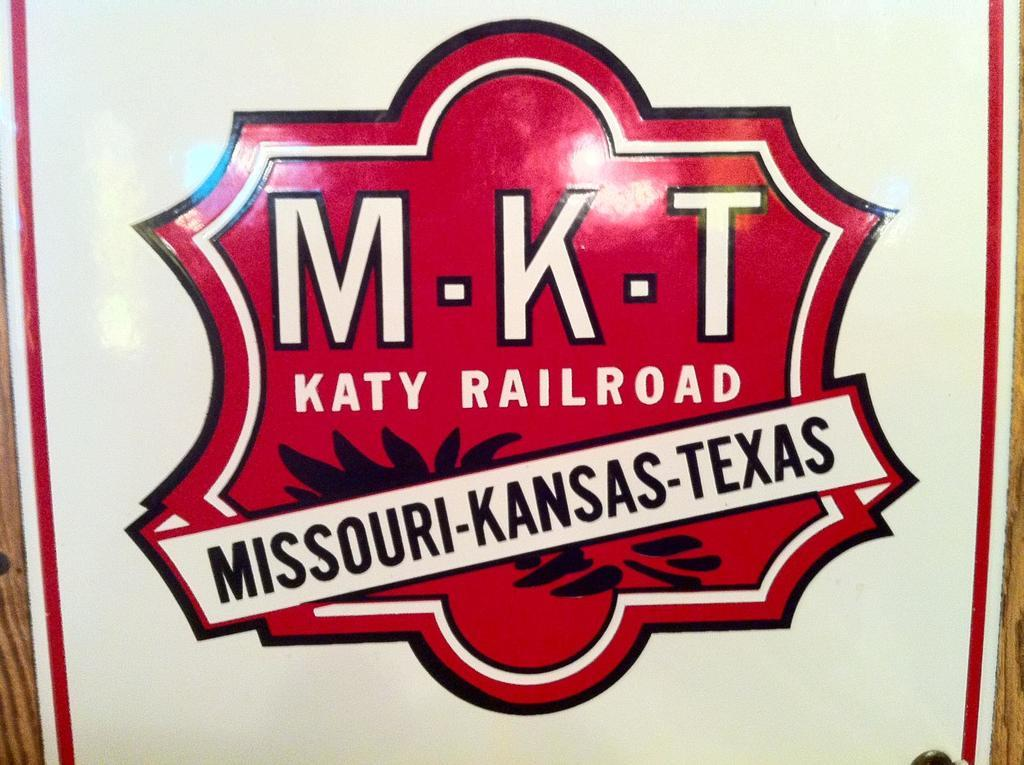What is located in the foreground of the image? There is a board in the foreground of the image. What is featured on the board? There is text on the board. What type of sock is hanging from the board in the image? There is no sock present in the image; it only features a board with text on it. 